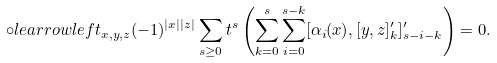Convert formula to latex. <formula><loc_0><loc_0><loc_500><loc_500>\circ l e a r r o w l e f t _ { x , y , z } ( - 1 ) ^ { | x | | z | } \sum _ { s \geq 0 } t ^ { s } \left ( \sum _ { k = 0 } ^ { s } \sum _ { i = 0 } ^ { s - k } [ \alpha _ { i } ( x ) , [ y , z ] ^ { \prime } _ { k } ] ^ { \prime } _ { s - i - k } \right ) = 0 .</formula> 